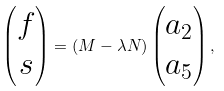Convert formula to latex. <formula><loc_0><loc_0><loc_500><loc_500>\begin{pmatrix} f \\ s \end{pmatrix} = \left ( M - \lambda N \right ) \begin{pmatrix} a _ { 2 } \\ a _ { 5 } \end{pmatrix} ,</formula> 